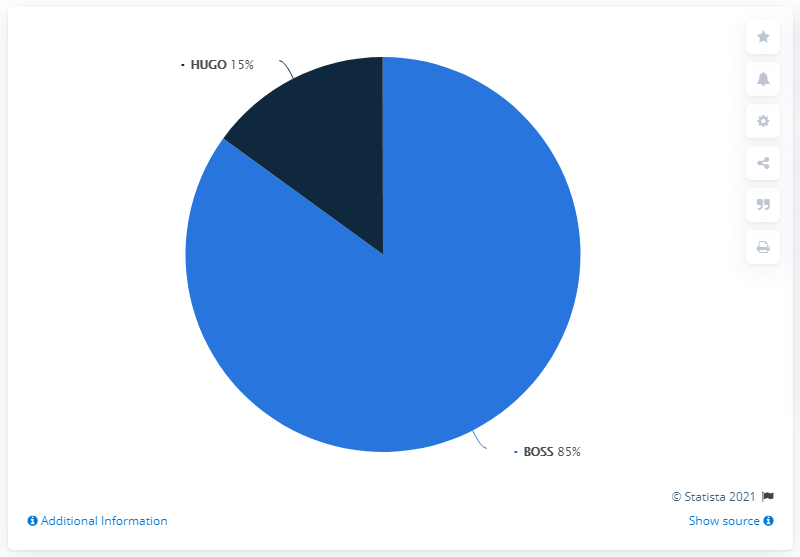Outline some significant characteristics in this image. The difference between the sales made by Boss and the average sales of Boss and Hugo is 35. The ratio of the blue segment to the navy blue segment is 5.67... 